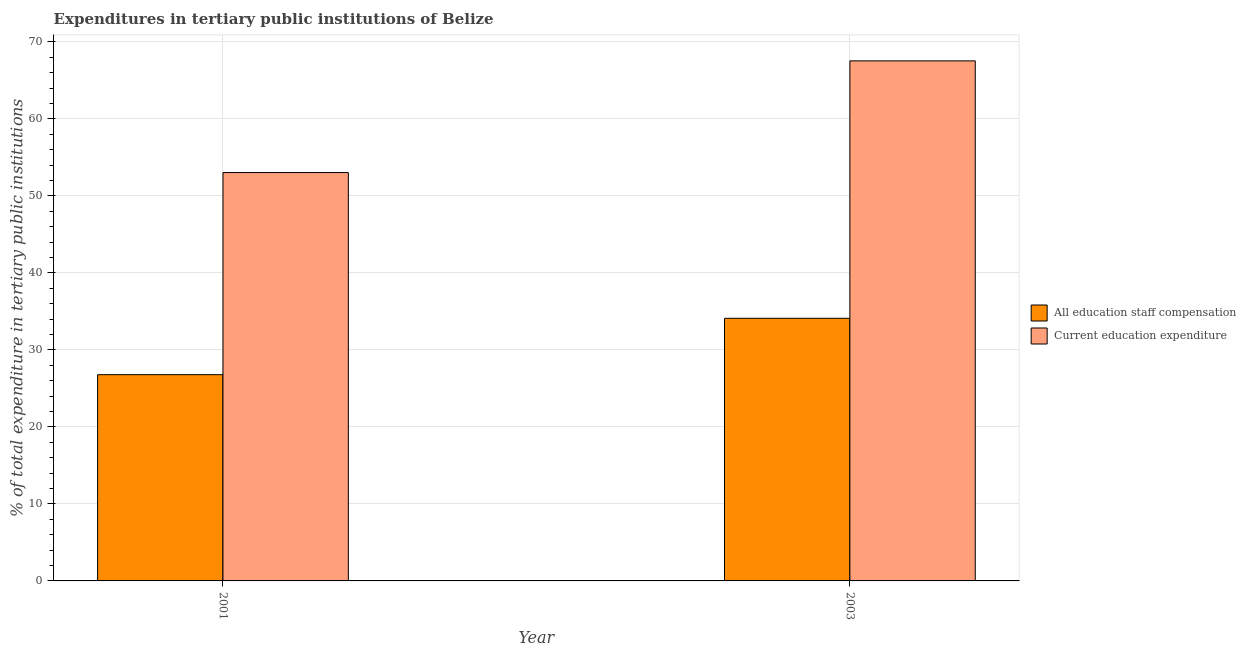How many different coloured bars are there?
Ensure brevity in your answer.  2. How many groups of bars are there?
Your answer should be very brief. 2. Are the number of bars on each tick of the X-axis equal?
Offer a terse response. Yes. How many bars are there on the 1st tick from the right?
Provide a short and direct response. 2. What is the label of the 1st group of bars from the left?
Offer a terse response. 2001. In how many cases, is the number of bars for a given year not equal to the number of legend labels?
Offer a very short reply. 0. What is the expenditure in staff compensation in 2003?
Your answer should be compact. 34.11. Across all years, what is the maximum expenditure in education?
Make the answer very short. 67.55. Across all years, what is the minimum expenditure in staff compensation?
Ensure brevity in your answer.  26.79. In which year was the expenditure in staff compensation maximum?
Give a very brief answer. 2003. In which year was the expenditure in education minimum?
Give a very brief answer. 2001. What is the total expenditure in staff compensation in the graph?
Your response must be concise. 60.9. What is the difference between the expenditure in education in 2001 and that in 2003?
Provide a succinct answer. -14.5. What is the difference between the expenditure in education in 2003 and the expenditure in staff compensation in 2001?
Make the answer very short. 14.5. What is the average expenditure in education per year?
Offer a very short reply. 60.3. In how many years, is the expenditure in staff compensation greater than 58 %?
Your response must be concise. 0. What is the ratio of the expenditure in education in 2001 to that in 2003?
Your response must be concise. 0.79. What does the 1st bar from the left in 2001 represents?
Offer a very short reply. All education staff compensation. What does the 2nd bar from the right in 2003 represents?
Provide a succinct answer. All education staff compensation. How many years are there in the graph?
Keep it short and to the point. 2. What is the difference between two consecutive major ticks on the Y-axis?
Provide a short and direct response. 10. Where does the legend appear in the graph?
Your answer should be very brief. Center right. How many legend labels are there?
Provide a short and direct response. 2. What is the title of the graph?
Keep it short and to the point. Expenditures in tertiary public institutions of Belize. Does "Crop" appear as one of the legend labels in the graph?
Provide a succinct answer. No. What is the label or title of the Y-axis?
Make the answer very short. % of total expenditure in tertiary public institutions. What is the % of total expenditure in tertiary public institutions in All education staff compensation in 2001?
Your answer should be very brief. 26.79. What is the % of total expenditure in tertiary public institutions in Current education expenditure in 2001?
Keep it short and to the point. 53.04. What is the % of total expenditure in tertiary public institutions in All education staff compensation in 2003?
Your answer should be very brief. 34.11. What is the % of total expenditure in tertiary public institutions in Current education expenditure in 2003?
Ensure brevity in your answer.  67.55. Across all years, what is the maximum % of total expenditure in tertiary public institutions in All education staff compensation?
Your answer should be very brief. 34.11. Across all years, what is the maximum % of total expenditure in tertiary public institutions in Current education expenditure?
Offer a terse response. 67.55. Across all years, what is the minimum % of total expenditure in tertiary public institutions in All education staff compensation?
Provide a short and direct response. 26.79. Across all years, what is the minimum % of total expenditure in tertiary public institutions in Current education expenditure?
Give a very brief answer. 53.04. What is the total % of total expenditure in tertiary public institutions in All education staff compensation in the graph?
Provide a succinct answer. 60.9. What is the total % of total expenditure in tertiary public institutions of Current education expenditure in the graph?
Your answer should be very brief. 120.59. What is the difference between the % of total expenditure in tertiary public institutions of All education staff compensation in 2001 and that in 2003?
Your answer should be compact. -7.33. What is the difference between the % of total expenditure in tertiary public institutions of Current education expenditure in 2001 and that in 2003?
Give a very brief answer. -14.51. What is the difference between the % of total expenditure in tertiary public institutions in All education staff compensation in 2001 and the % of total expenditure in tertiary public institutions in Current education expenditure in 2003?
Provide a short and direct response. -40.76. What is the average % of total expenditure in tertiary public institutions of All education staff compensation per year?
Keep it short and to the point. 30.45. What is the average % of total expenditure in tertiary public institutions of Current education expenditure per year?
Ensure brevity in your answer.  60.3. In the year 2001, what is the difference between the % of total expenditure in tertiary public institutions in All education staff compensation and % of total expenditure in tertiary public institutions in Current education expenditure?
Keep it short and to the point. -26.25. In the year 2003, what is the difference between the % of total expenditure in tertiary public institutions of All education staff compensation and % of total expenditure in tertiary public institutions of Current education expenditure?
Give a very brief answer. -33.43. What is the ratio of the % of total expenditure in tertiary public institutions of All education staff compensation in 2001 to that in 2003?
Your answer should be very brief. 0.79. What is the ratio of the % of total expenditure in tertiary public institutions in Current education expenditure in 2001 to that in 2003?
Offer a very short reply. 0.79. What is the difference between the highest and the second highest % of total expenditure in tertiary public institutions of All education staff compensation?
Make the answer very short. 7.33. What is the difference between the highest and the second highest % of total expenditure in tertiary public institutions in Current education expenditure?
Offer a very short reply. 14.51. What is the difference between the highest and the lowest % of total expenditure in tertiary public institutions of All education staff compensation?
Keep it short and to the point. 7.33. What is the difference between the highest and the lowest % of total expenditure in tertiary public institutions of Current education expenditure?
Provide a succinct answer. 14.51. 